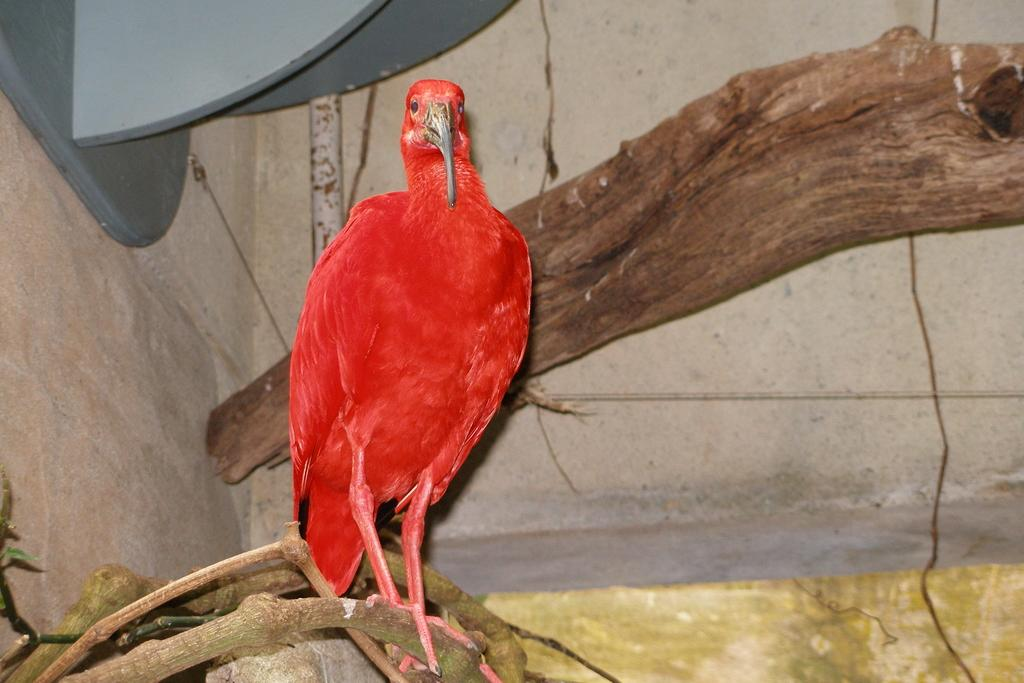What type of animal is present in the image? There is a bird in the image. What color is the bird? The bird is red in color. What can be seen in the background of the image? Tree branches are visible in the image. What type of structure is present in the image? There is a wall in the image. How many buttons are on the bird's wings in the image? There are no buttons present on the bird's wings in the image. 